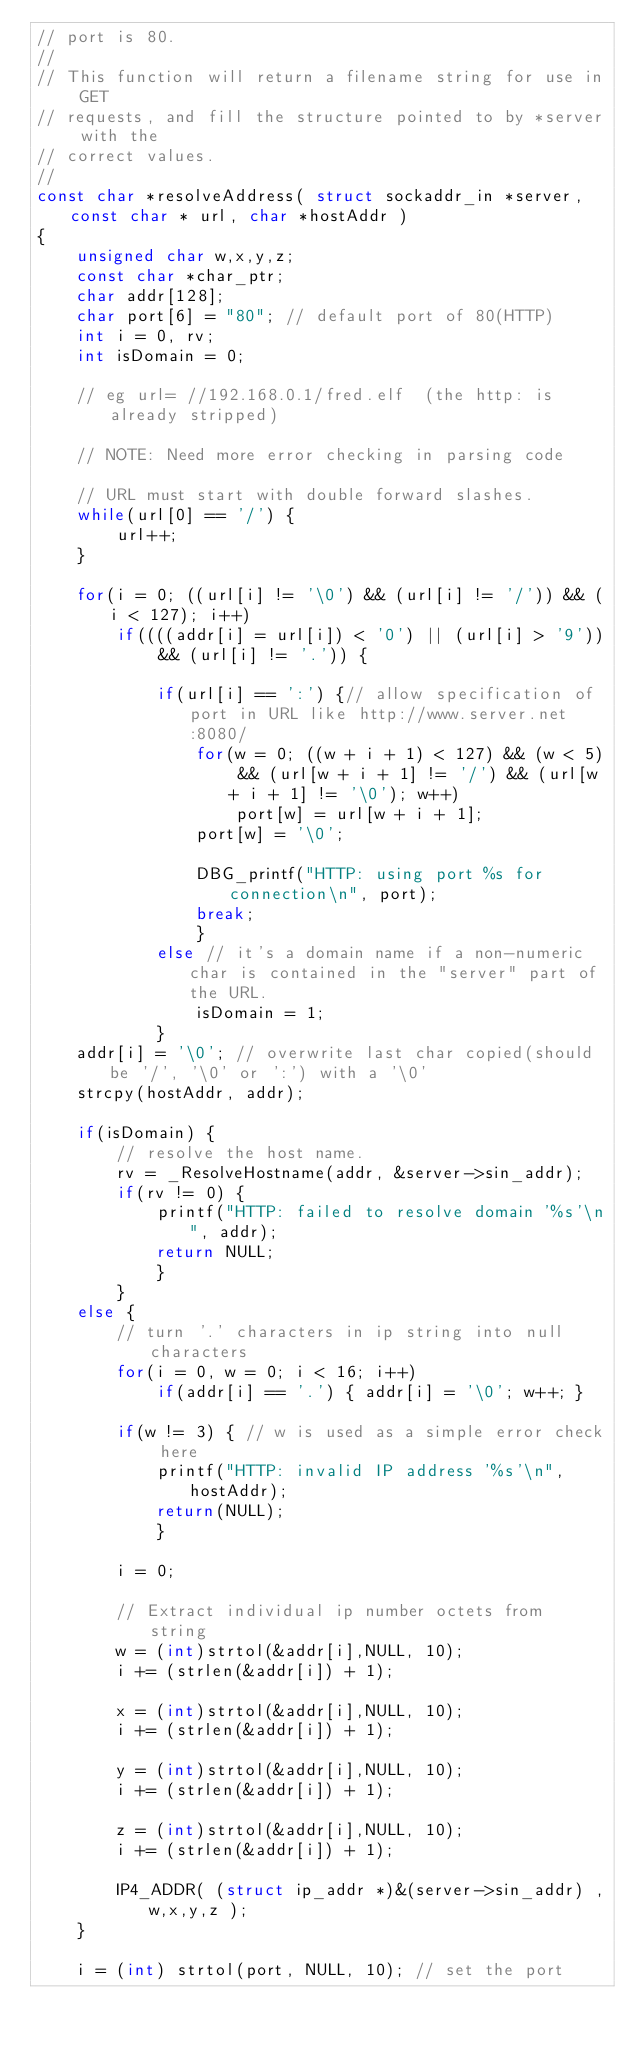<code> <loc_0><loc_0><loc_500><loc_500><_C_>// port is 80.
//
// This function will return a filename string for use in GET
// requests, and fill the structure pointed to by *server with the
// correct values.
//
const char *resolveAddress( struct sockaddr_in *server, const char * url, char *hostAddr )
{
	unsigned char w,x,y,z;
	const char *char_ptr;
	char addr[128];
	char port[6] = "80"; // default port of 80(HTTP)
	int i = 0, rv;
	int isDomain = 0;

	// eg url= //192.168.0.1/fred.elf  (the http: is already stripped)

	// NOTE: Need more error checking in parsing code

	// URL must start with double forward slashes.
	while(url[0] == '/') {
		url++;
	}

	for(i = 0; ((url[i] != '\0') && (url[i] != '/')) && (i < 127); i++)
	    if((((addr[i] = url[i]) < '0') || (url[i] > '9')) && (url[i] != '.')) {

	        if(url[i] == ':') {// allow specification of port in URL like http://www.server.net:8080/
	            for(w = 0; ((w + i + 1) < 127) && (w < 5) && (url[w + i + 1] != '/') && (url[w + i + 1] != '\0'); w++)
	                port[w] = url[w + i + 1];
	            port[w] = '\0';

	            DBG_printf("HTTP: using port %s for connection\n", port);
	            break;
	            }
            else // it's a domain name if a non-numeric char is contained in the "server" part of the URL.
	            isDomain = 1;
	        }
    addr[i] = '\0'; // overwrite last char copied(should be '/', '\0' or ':') with a '\0'
    strcpy(hostAddr, addr);

    if(isDomain) {
		// resolve the host name.
		rv = _ResolveHostname(addr, &server->sin_addr);
		if(rv != 0) {
		    printf("HTTP: failed to resolve domain '%s'\n", addr);
			return NULL;
			}
        }
    else {
		// turn '.' characters in ip string into null characters
		for(i = 0, w = 0; i < 16; i++)
			if(addr[i] == '.') { addr[i] = '\0'; w++; }

        if(w != 3) { // w is used as a simple error check here
            printf("HTTP: invalid IP address '%s'\n", hostAddr);
            return(NULL);
            }

		i = 0;

		// Extract individual ip number octets from string
		w = (int)strtol(&addr[i],NULL, 10);
		i += (strlen(&addr[i]) + 1);

		x = (int)strtol(&addr[i],NULL, 10);
		i += (strlen(&addr[i]) + 1);

		y = (int)strtol(&addr[i],NULL, 10);
		i += (strlen(&addr[i]) + 1);

		z = (int)strtol(&addr[i],NULL, 10);
		i += (strlen(&addr[i]) + 1);

		IP4_ADDR( (struct ip_addr *)&(server->sin_addr) ,w,x,y,z );
	}

    i = (int) strtol(port, NULL, 10); // set the port</code> 